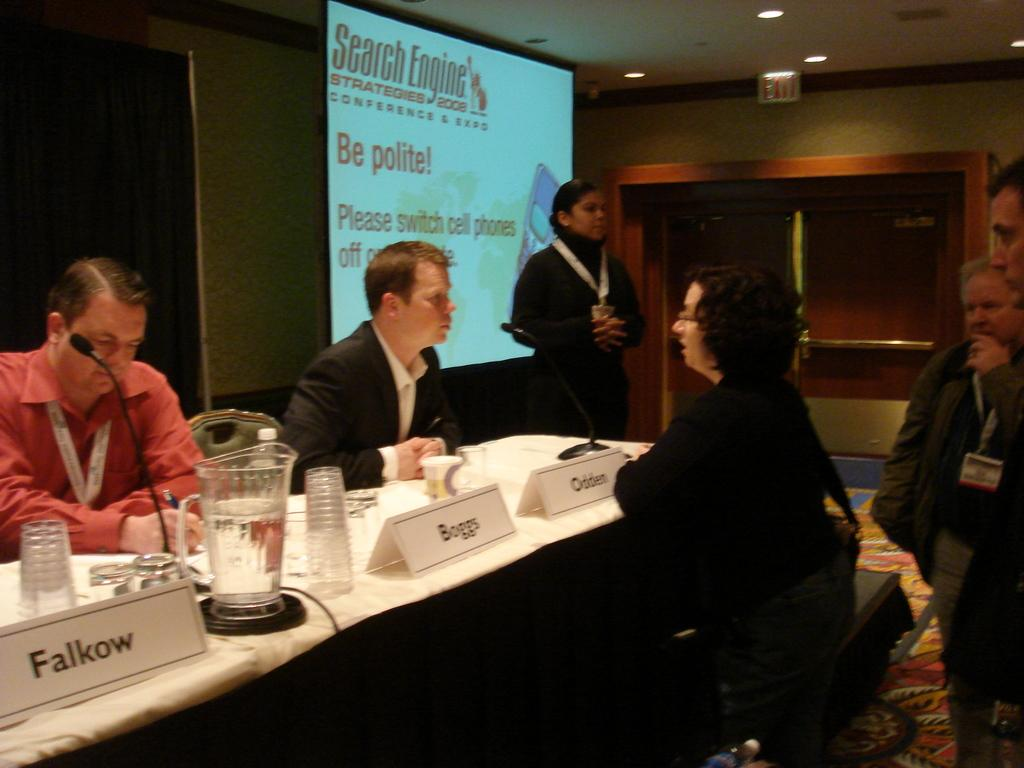How many people are in the image? There is a group of people in the image, but the exact number is not specified. What are the people in the image doing? Some people are sitting, and some are standing. What is present on the table in the image? There is a table in the image, but the contents are not specified. What can be used for identification purposes in the image? There are name boards in the image. What can be used for amplifying sound in the image? There are microphones (mics) in the image. What can be used for displaying information in the image? There is a screen in the image. What color is the secretary's tongue in the image? There is no secretary present in the image. 